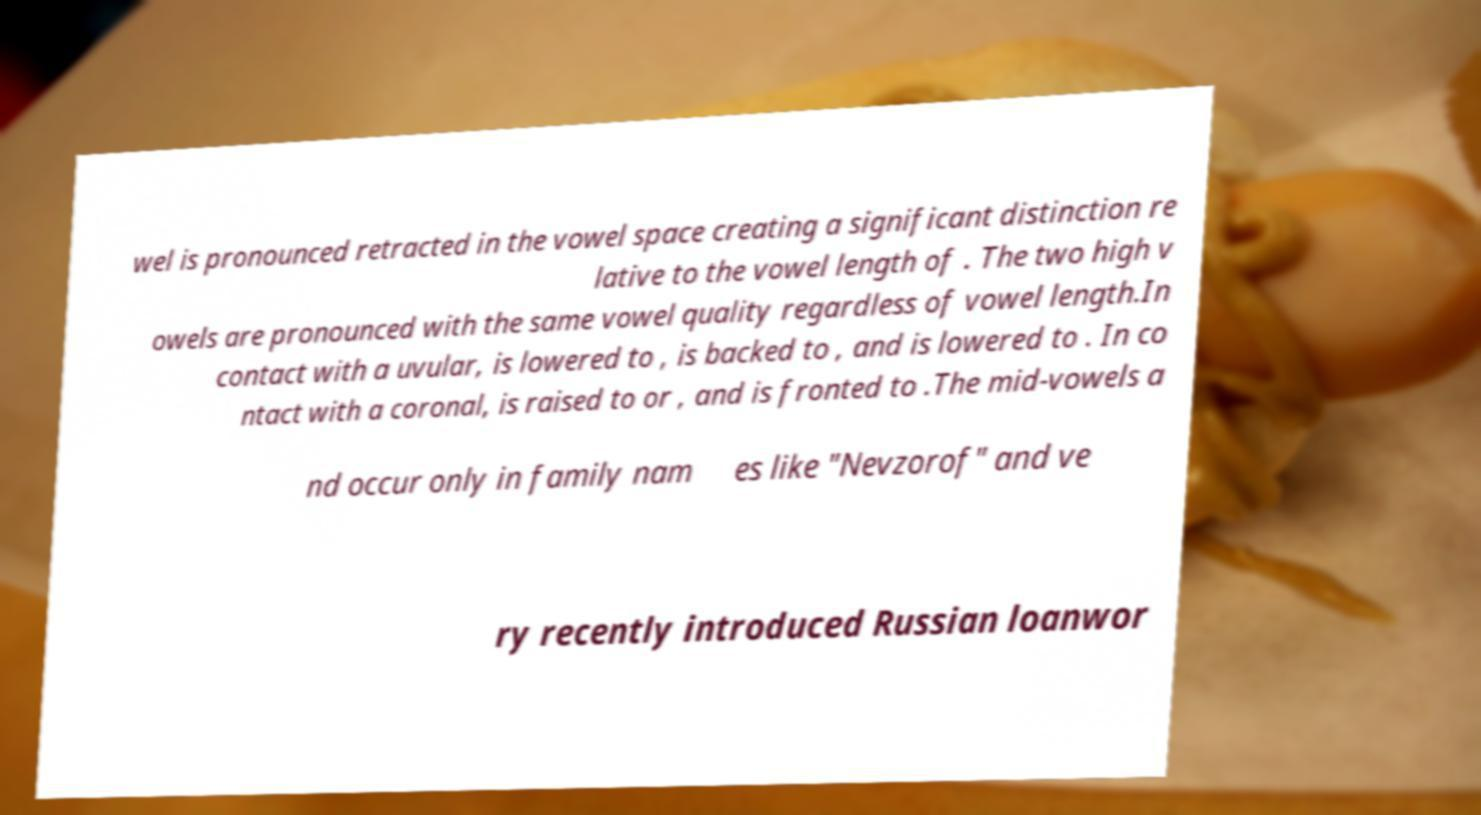There's text embedded in this image that I need extracted. Can you transcribe it verbatim? wel is pronounced retracted in the vowel space creating a significant distinction re lative to the vowel length of . The two high v owels are pronounced with the same vowel quality regardless of vowel length.In contact with a uvular, is lowered to , is backed to , and is lowered to . In co ntact with a coronal, is raised to or , and is fronted to .The mid-vowels a nd occur only in family nam es like "Nevzorof" and ve ry recently introduced Russian loanwor 